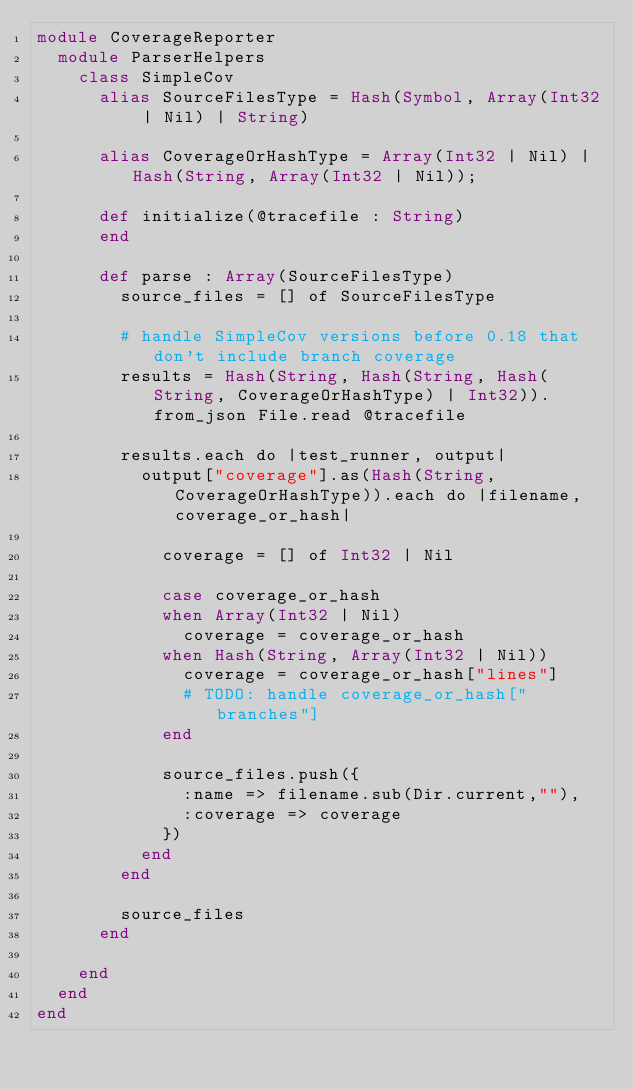Convert code to text. <code><loc_0><loc_0><loc_500><loc_500><_Crystal_>module CoverageReporter
  module ParserHelpers
    class SimpleCov
      alias SourceFilesType = Hash(Symbol, Array(Int32 | Nil) | String)

      alias CoverageOrHashType = Array(Int32 | Nil) | Hash(String, Array(Int32 | Nil));

      def initialize(@tracefile : String)
      end

      def parse : Array(SourceFilesType)
        source_files = [] of SourceFilesType

        # handle SimpleCov versions before 0.18 that don't include branch coverage
        results = Hash(String, Hash(String, Hash(String, CoverageOrHashType) | Int32)).from_json File.read @tracefile

        results.each do |test_runner, output|
          output["coverage"].as(Hash(String, CoverageOrHashType)).each do |filename, coverage_or_hash|

            coverage = [] of Int32 | Nil

            case coverage_or_hash
            when Array(Int32 | Nil)
              coverage = coverage_or_hash
            when Hash(String, Array(Int32 | Nil))
              coverage = coverage_or_hash["lines"]
              # TODO: handle coverage_or_hash["branches"]
            end

            source_files.push({
              :name => filename.sub(Dir.current,""), 
              :coverage => coverage
            })
          end
        end

        source_files
      end

    end
  end
end
</code> 